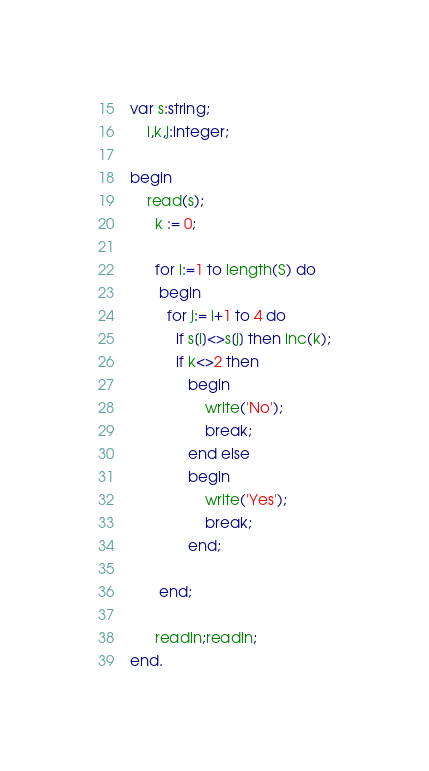Convert code to text. <code><loc_0><loc_0><loc_500><loc_500><_Pascal_>var s:string;
    i,k,j:integer;
    
begin
    read(s);
      k := 0;

      for i:=1 to length(S) do 
       begin
         for j:= i+1 to 4 do
           if s[i]<>s[j] then inc(k);
           if k<>2 then 
              begin
                  write('No');
                  break;
              end else 
              begin
                  write('Yes');
                  break;
              end;
           
       end;
  
      readln;readln;
end.     </code> 